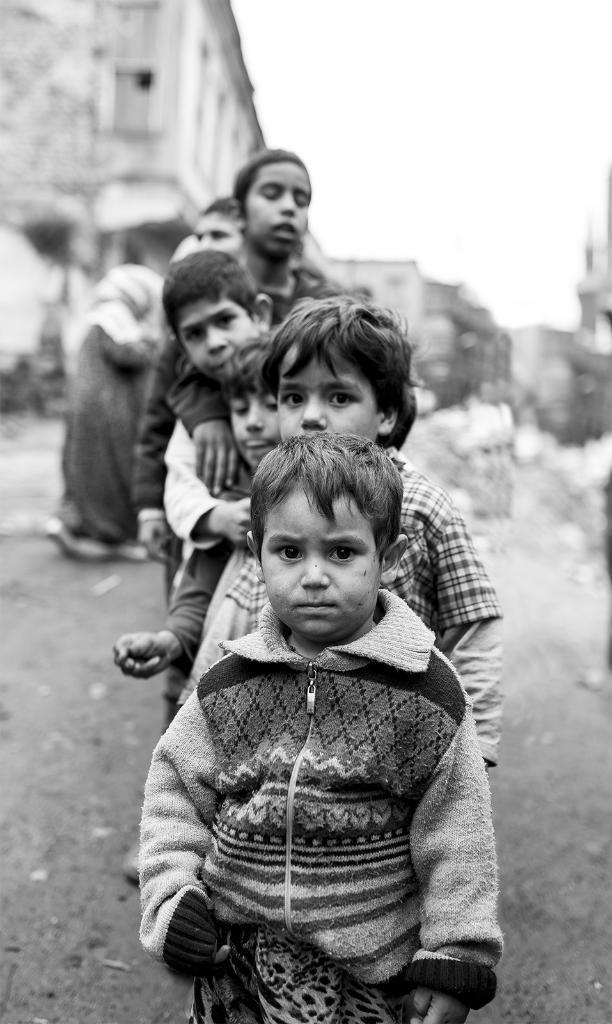Could you give a brief overview of what you see in this image? In this picture we can see few people, behind them we can find few buildings, it is a black and white photography. 